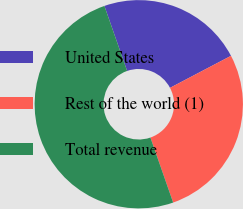Convert chart. <chart><loc_0><loc_0><loc_500><loc_500><pie_chart><fcel>United States<fcel>Rest of the world (1)<fcel>Total revenue<nl><fcel>22.66%<fcel>27.34%<fcel>50.0%<nl></chart> 